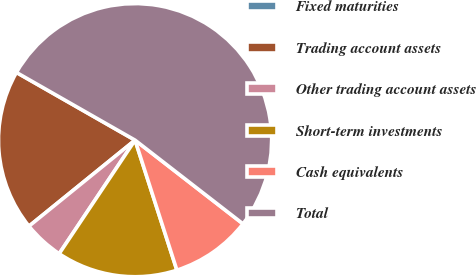Convert chart to OTSL. <chart><loc_0><loc_0><loc_500><loc_500><pie_chart><fcel>Fixed maturities<fcel>Trading account assets<fcel>Other trading account assets<fcel>Short-term investments<fcel>Cash equivalents<fcel>Total<nl><fcel>0.0%<fcel>19.1%<fcel>4.78%<fcel>14.33%<fcel>9.55%<fcel>52.24%<nl></chart> 